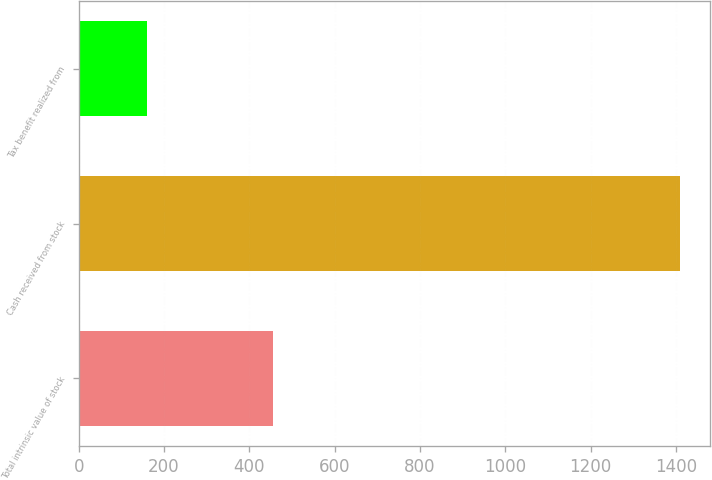<chart> <loc_0><loc_0><loc_500><loc_500><bar_chart><fcel>Total intrinsic value of stock<fcel>Cash received from stock<fcel>Tax benefit realized from<nl><fcel>456<fcel>1410<fcel>160<nl></chart> 